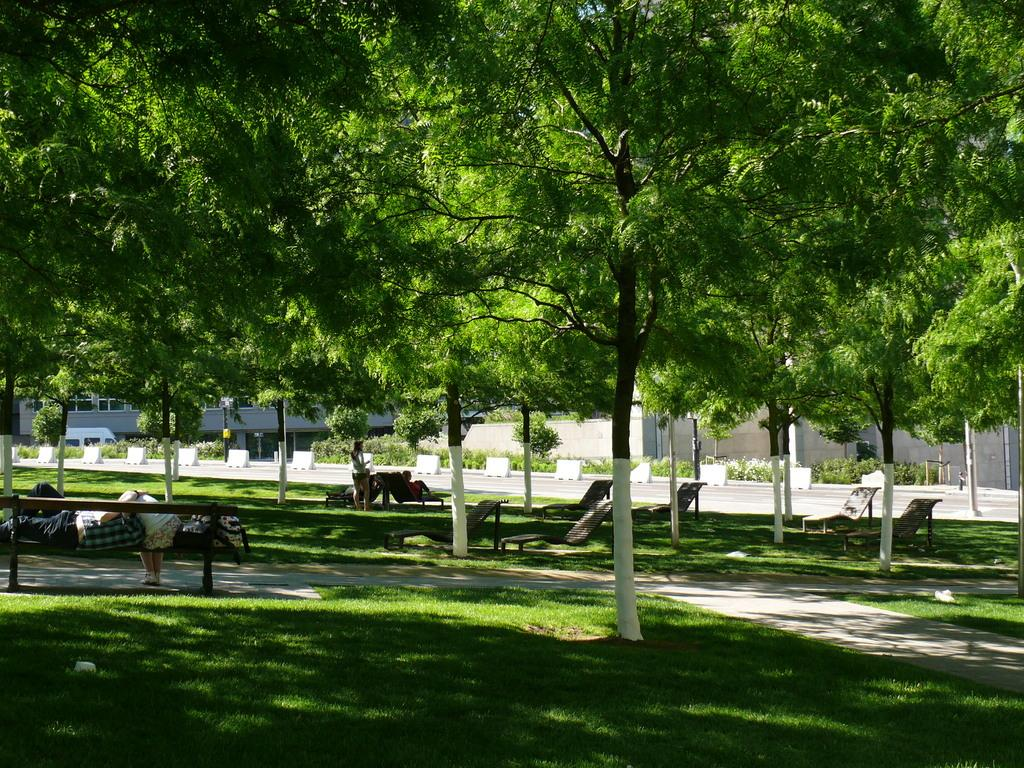How many people are in the image? There is a group of people in the image, but the exact number cannot be determined from the provided facts. What type of seating is available in the image? There is a bench and chairs in the image. What type of vegetation can be seen in the image? There are plants, grass, and trees in the image. What type of structure is present in the image? There is a building in the image. Is there any transportation visible in the image? Yes, there is a vehicle in the image. Can you see a receipt for the volleyball game in the image? There is no mention of a volleyball game or a receipt in the provided facts, so we cannot determine if one is present in the image. Is there a spark coming from the building in the image? There is no mention of a spark or any indication of a fire or electrical issue in the provided facts, so we cannot determine if one is present in the image. 